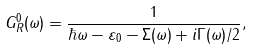<formula> <loc_0><loc_0><loc_500><loc_500>G _ { R } ^ { 0 } ( \omega ) = \frac { 1 } { \hbar { \omega } - \varepsilon _ { 0 } - \Sigma ( \omega ) + i \Gamma ( \omega ) / 2 } ,</formula> 